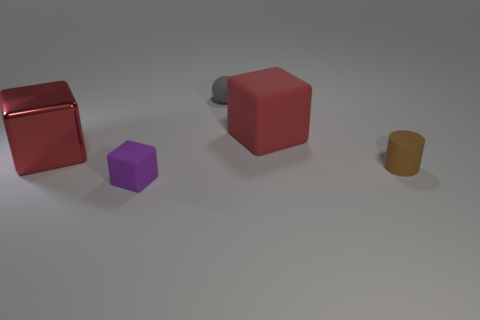Is the color of the big block that is behind the large shiny cube the same as the rubber sphere?
Your response must be concise. No. Are there any tiny purple objects that are behind the purple matte object that is in front of the big block that is behind the large shiny block?
Your answer should be compact. No. The tiny object that is in front of the big red matte block and to the right of the tiny block has what shape?
Offer a very short reply. Cylinder. Is there a matte object that has the same color as the tiny matte cylinder?
Provide a succinct answer. No. What color is the big thing that is on the right side of the red cube that is left of the sphere?
Your response must be concise. Red. There is a thing that is to the right of the red cube that is to the right of the big red cube that is in front of the large red matte object; what size is it?
Ensure brevity in your answer.  Small. Do the small brown cylinder and the red thing that is right of the big red metal object have the same material?
Provide a short and direct response. Yes. There is a red object that is the same material as the tiny brown object; what is its size?
Your response must be concise. Large. Is there another thing that has the same shape as the tiny purple matte thing?
Make the answer very short. Yes. How many objects are red cubes that are on the left side of the tiny gray rubber object or blue matte cylinders?
Your response must be concise. 1. 